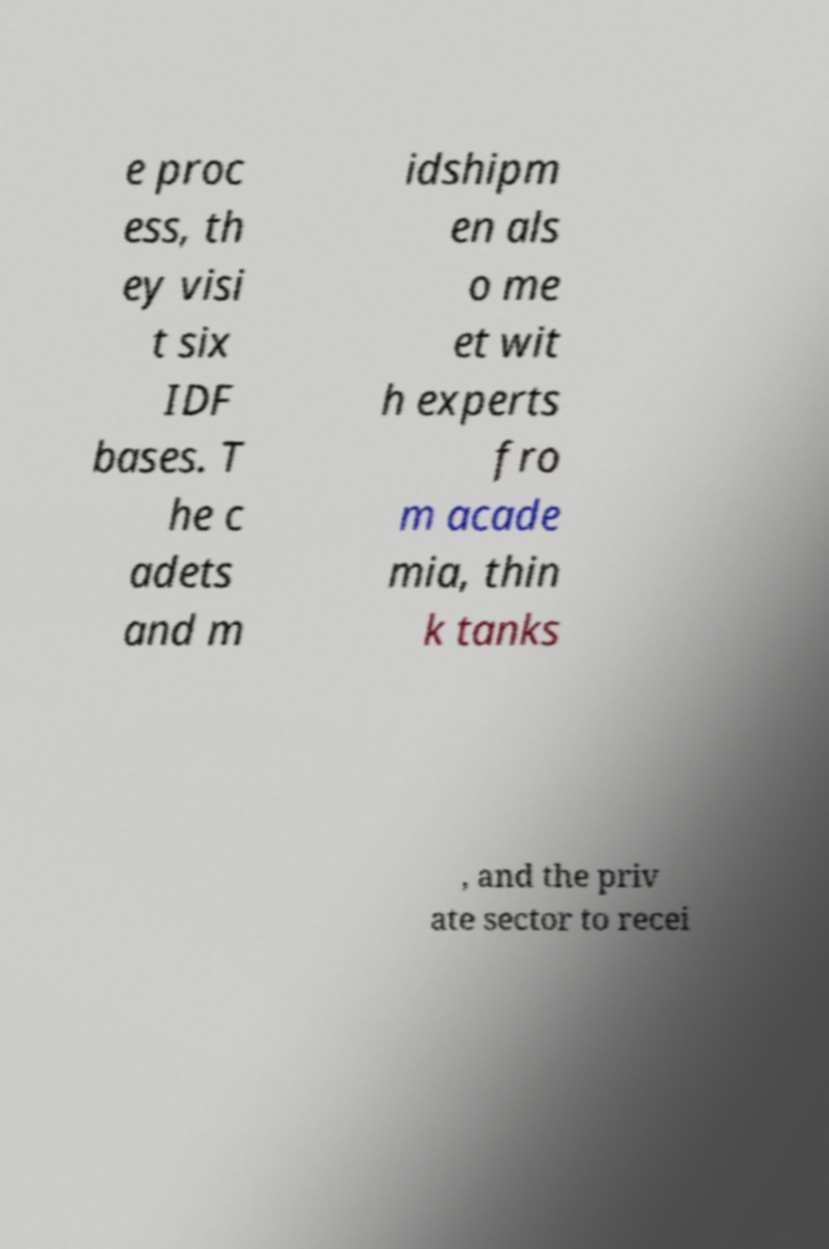Please identify and transcribe the text found in this image. e proc ess, th ey visi t six IDF bases. T he c adets and m idshipm en als o me et wit h experts fro m acade mia, thin k tanks , and the priv ate sector to recei 